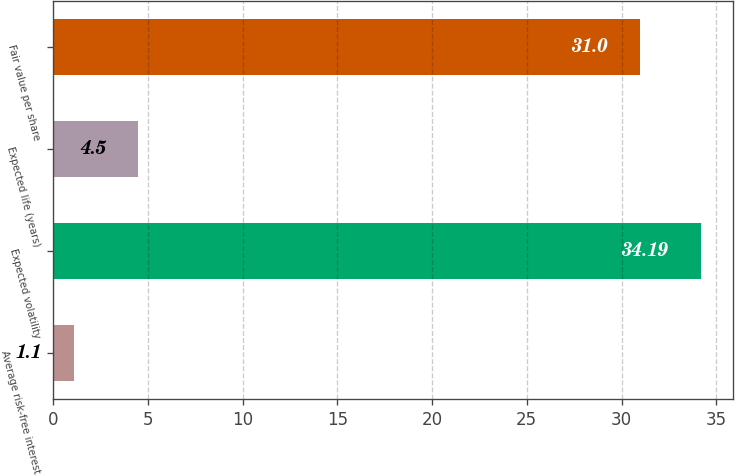Convert chart. <chart><loc_0><loc_0><loc_500><loc_500><bar_chart><fcel>Average risk-free interest<fcel>Expected volatility<fcel>Expected life (years)<fcel>Fair value per share<nl><fcel>1.1<fcel>34.19<fcel>4.5<fcel>31<nl></chart> 